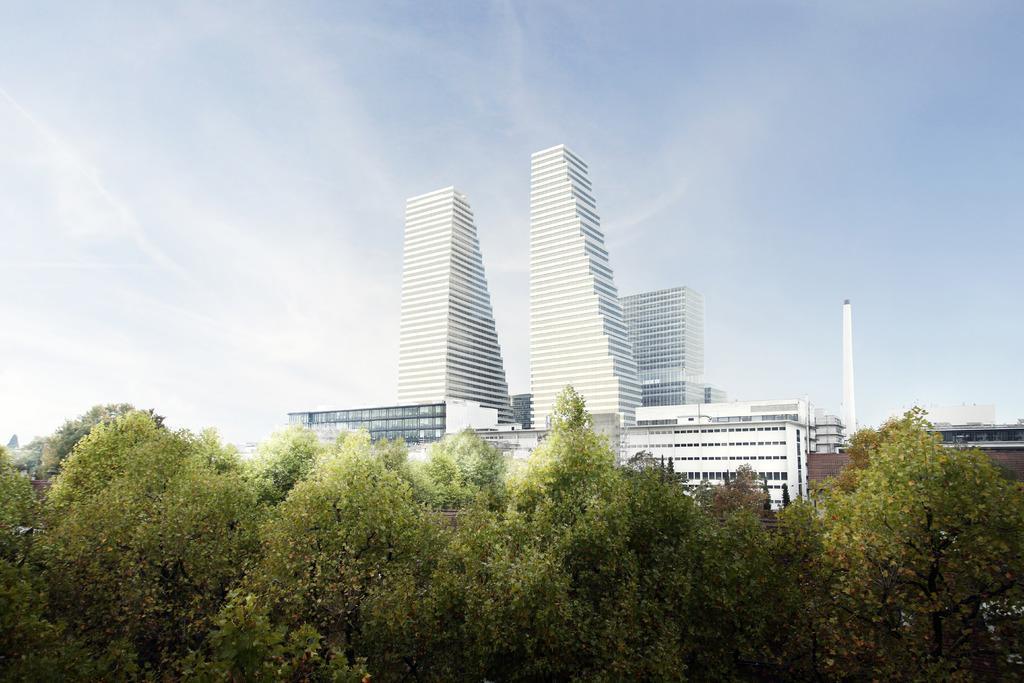In one or two sentences, can you explain what this image depicts? In this image, we can see some buildings, trees and a white colored object. We can also see the sky. 